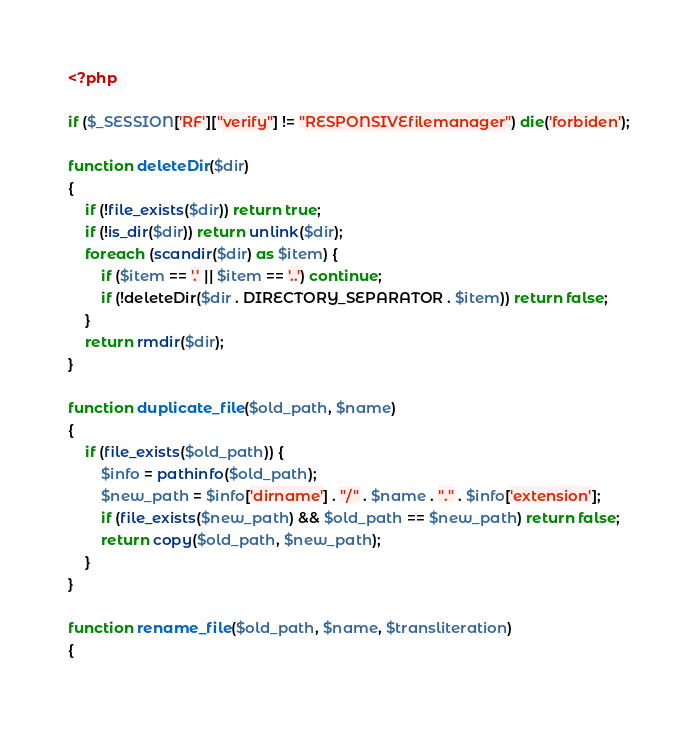Convert code to text. <code><loc_0><loc_0><loc_500><loc_500><_PHP_><?php

if ($_SESSION['RF']["verify"] != "RESPONSIVEfilemanager") die('forbiden');

function deleteDir($dir)
{
    if (!file_exists($dir)) return true;
    if (!is_dir($dir)) return unlink($dir);
    foreach (scandir($dir) as $item) {
        if ($item == '.' || $item == '..') continue;
        if (!deleteDir($dir . DIRECTORY_SEPARATOR . $item)) return false;
    }
    return rmdir($dir);
}

function duplicate_file($old_path, $name)
{
    if (file_exists($old_path)) {
        $info = pathinfo($old_path);
        $new_path = $info['dirname'] . "/" . $name . "." . $info['extension'];
        if (file_exists($new_path) && $old_path == $new_path) return false;
        return copy($old_path, $new_path);
    }
}

function rename_file($old_path, $name, $transliteration)
{</code> 